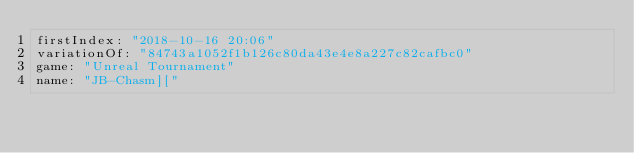Convert code to text. <code><loc_0><loc_0><loc_500><loc_500><_YAML_>firstIndex: "2018-10-16 20:06"
variationOf: "84743a1052f1b126c80da43e4e8a227c82cafbc0"
game: "Unreal Tournament"
name: "JB-Chasm]["</code> 